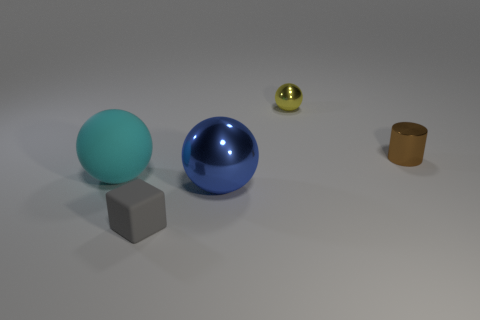Add 2 small rubber balls. How many objects exist? 7 Subtract all spheres. How many objects are left? 2 Subtract all matte things. Subtract all yellow shiny cylinders. How many objects are left? 3 Add 2 blue metal balls. How many blue metal balls are left? 3 Add 2 blue objects. How many blue objects exist? 3 Subtract 0 blue cylinders. How many objects are left? 5 